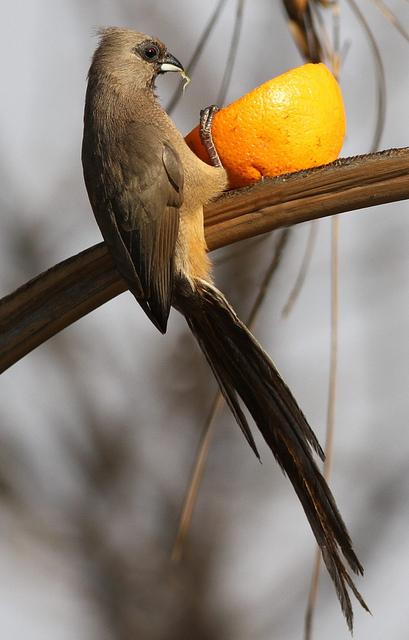What is the bird eating?
Quick response, please. Orange. What kind of bird is this?
Short answer required. Hummingbird. What type of fruit does the bird have?
Answer briefly. Orange. How many birds are there?
Be succinct. 1. 